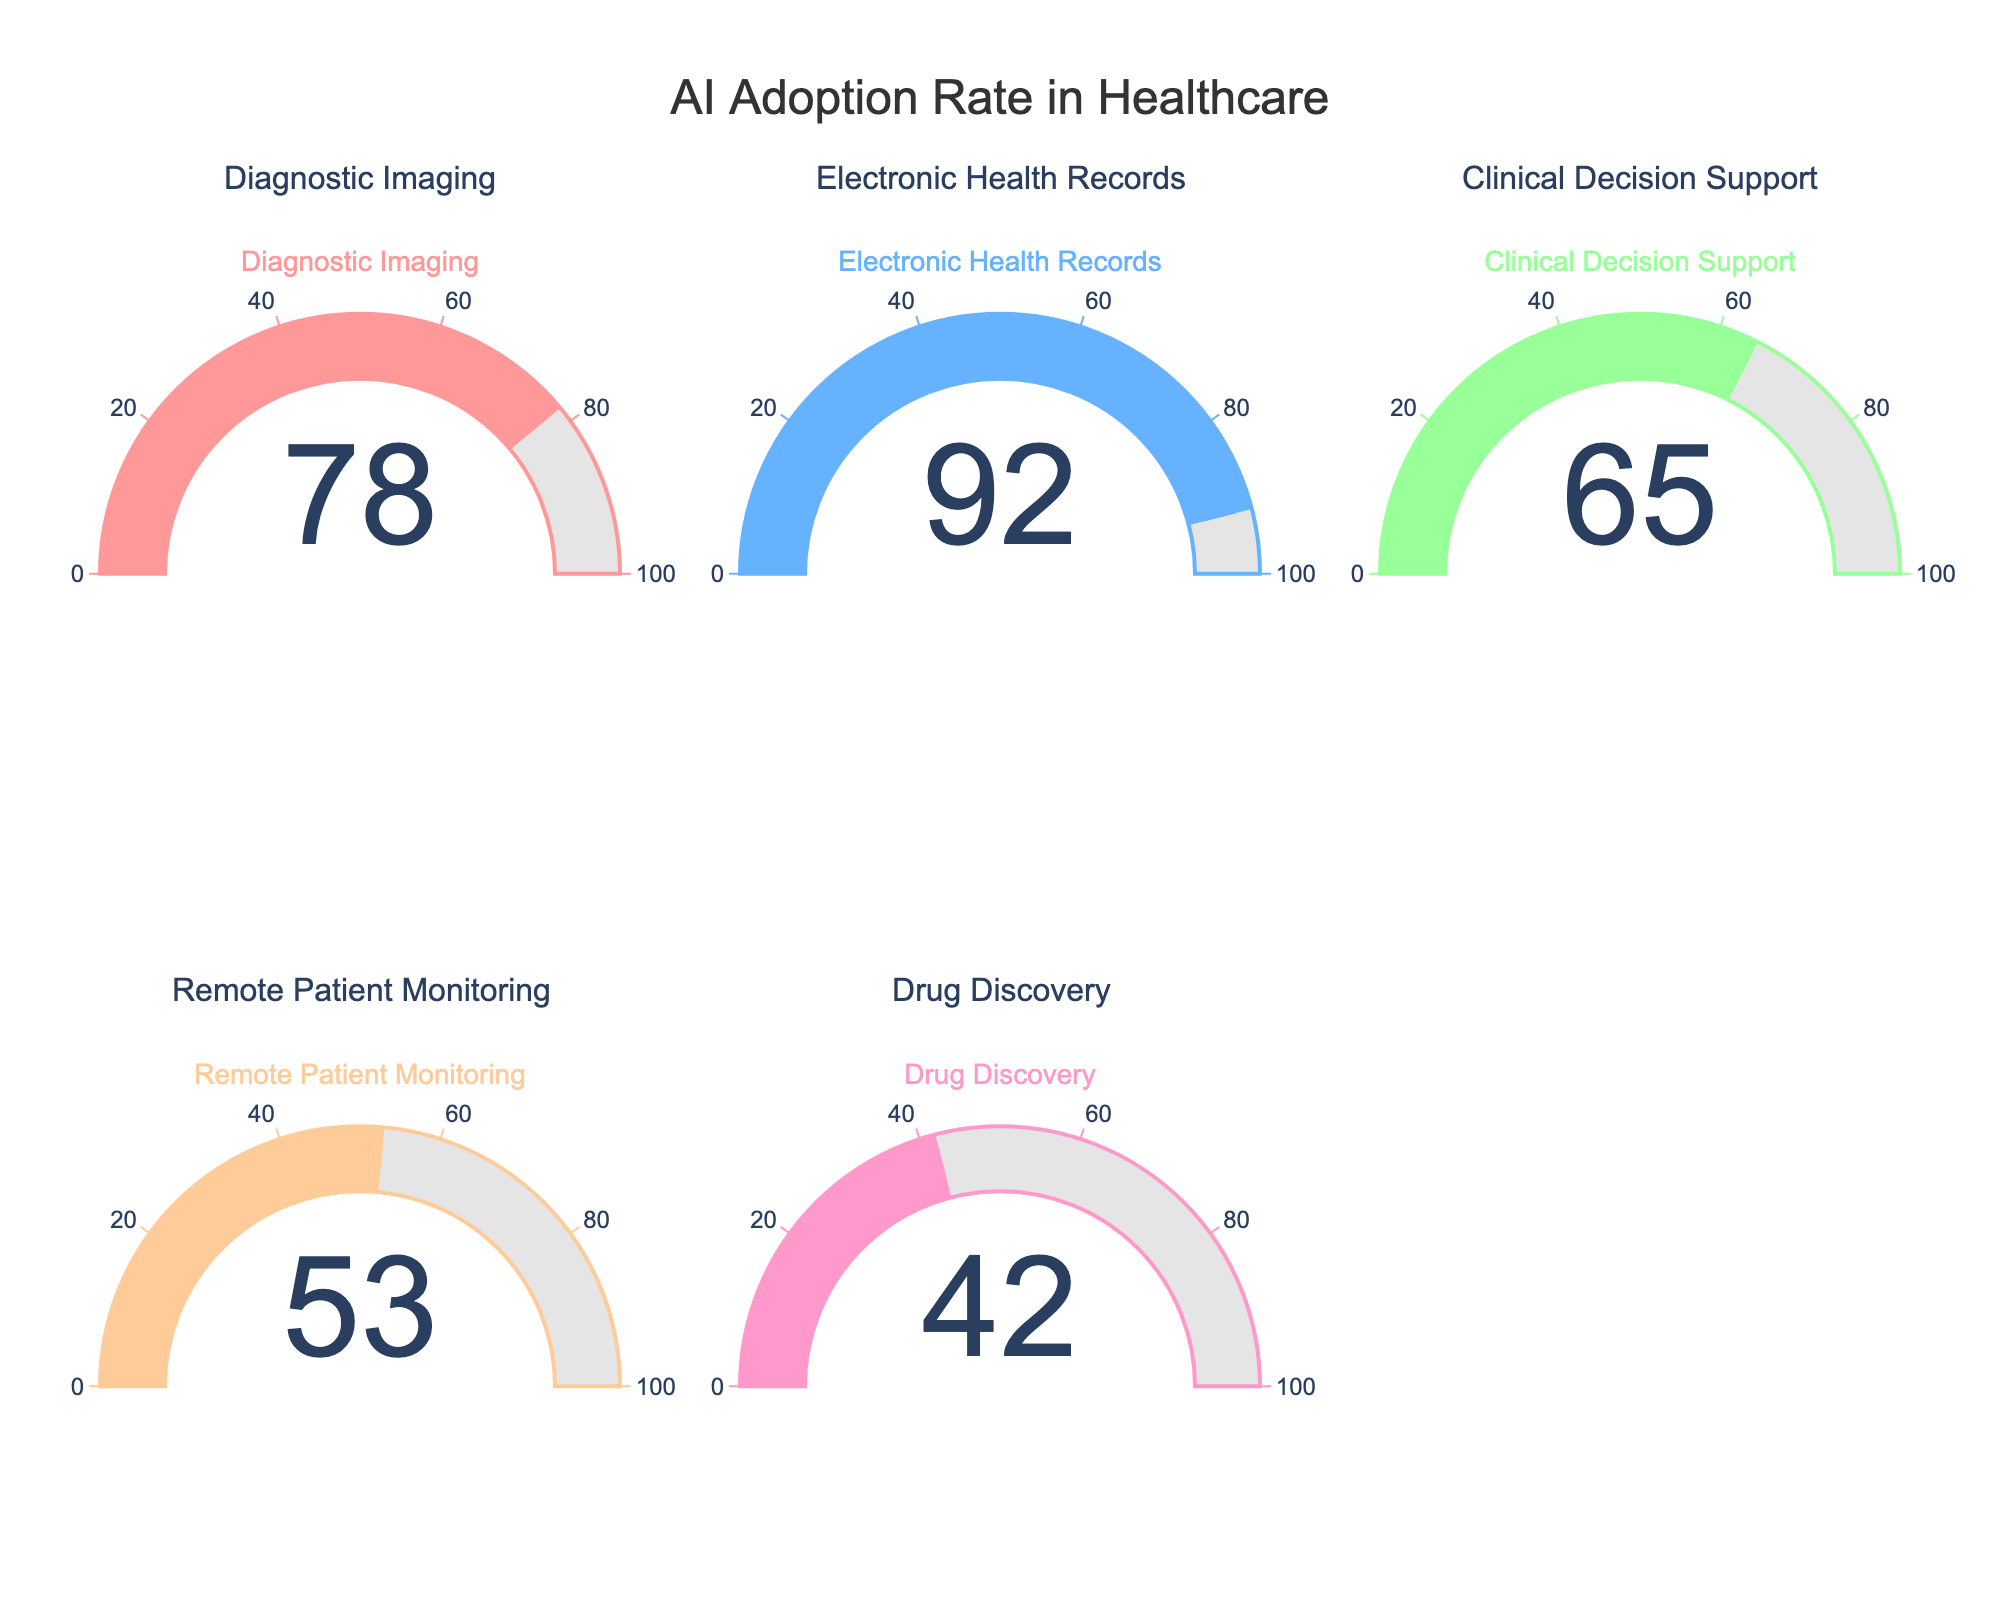What is the adoption rate of AI in Electronic Health Records? The gauge for Electronic Health Records shows a number, which is the adoption rate.
Answer: 92 Which category has the lowest adoption rate of AI? By comparing the numbers displayed on each gauge, the lowest value is seen on the Drug Discovery gauge.
Answer: Drug Discovery What is the combined adoption rate of AI for Diagnostic Imaging and Clinical Decision Support? Summing the adoption rates shown for Diagnostic Imaging (78) and Clinical Decision Support (65) gives 78 + 65.
Answer: 143 How many categories have an adoption rate above 60? By examining the gauges, the categories with values above 60 are Diagnostic Imaging (78), Electronic Health Records (92), and Clinical Decision Support (65). This makes a total of 3 categories.
Answer: 3 What is the average adoption rate of AI across all categories? Adding the adoption rates for all categories (78 + 92 + 65 + 53 + 42) gives 330. Dividing this sum by the number of categories (5), we get 330 / 5.
Answer: 66 What is the difference in adoption rates between Remote Patient Monitoring and Drug Discovery? The adoption rates are 53 for Remote Patient Monitoring and 42 for Drug Discovery. The difference is 53 - 42.
Answer: 11 Which category has the second highest AI adoption rate? The highest rate is for Electronic Health Records (92). The second highest adoption rate is for Diagnostic Imaging (78).
Answer: Diagnostic Imaging Is the adoption rate of AI in Drug Discovery less than half of that in Electronic Health Records? The adoption rate for Drug Discovery is 42, while for Electronic Health Records, it is 92. Calculating half of 92, which is 46, we find that 42 is indeed less than 46.
Answer: Yes 